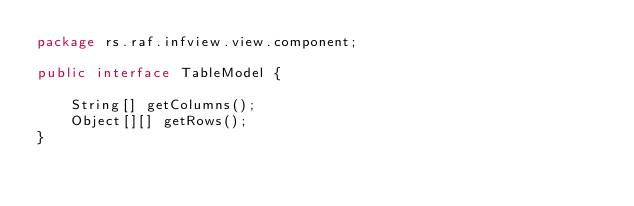Convert code to text. <code><loc_0><loc_0><loc_500><loc_500><_Java_>package rs.raf.infview.view.component;

public interface TableModel {

    String[] getColumns();
    Object[][] getRows();
}</code> 